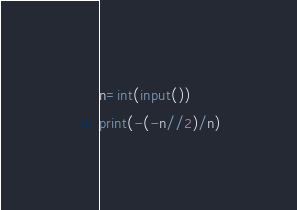Convert code to text. <code><loc_0><loc_0><loc_500><loc_500><_Python_>n=int(input())
print(-(-n//2)/n)</code> 